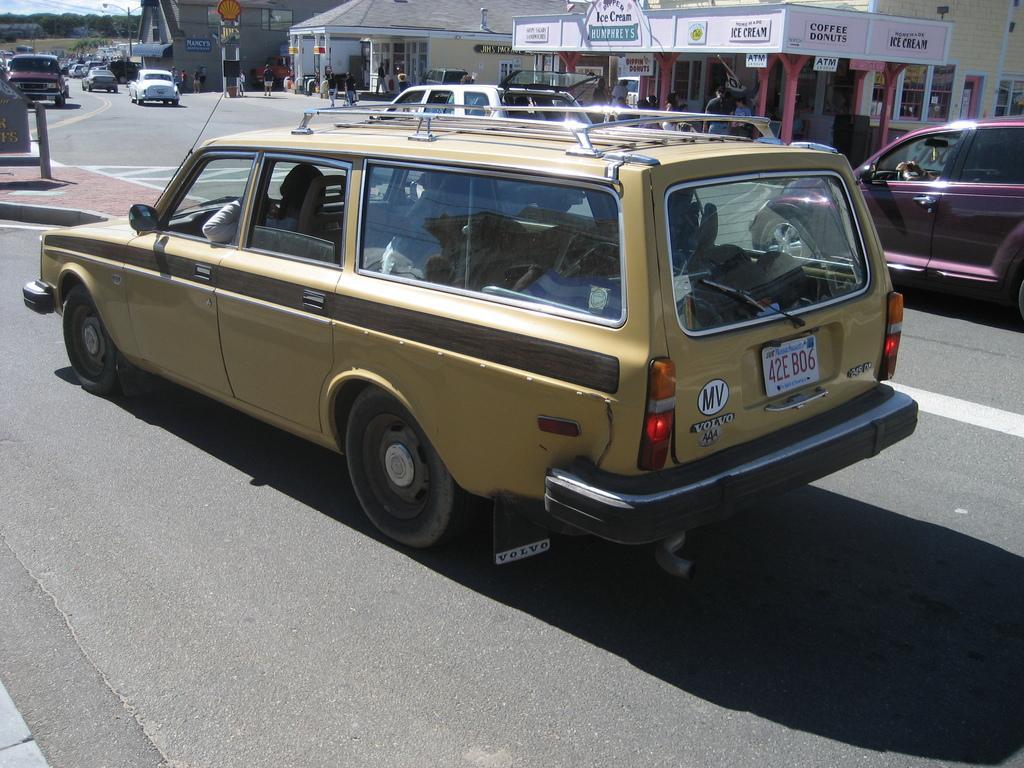Describe this image in one or two sentences. This picture shows few cars moving on the road and we see few buildings on the side and we see trees and a pole light. 